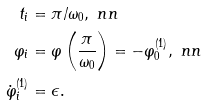<formula> <loc_0><loc_0><loc_500><loc_500>t _ { i } & = \pi / \omega _ { 0 } , \ n n \\ \varphi _ { i } & = \varphi \left ( \frac { \pi } { \omega _ { 0 } } \right ) = - \varphi ^ { ( 1 ) } _ { 0 } , \ n n \\ \dot { \varphi } ^ { ( 1 ) } _ { i } & = \epsilon .</formula> 